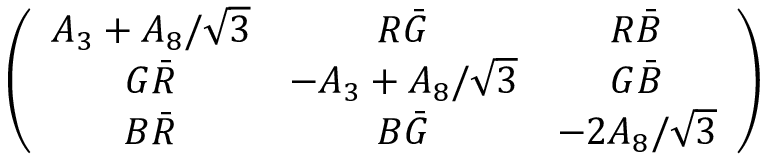Convert formula to latex. <formula><loc_0><loc_0><loc_500><loc_500>\left ( \begin{array} { c c c } { { A _ { 3 } + A _ { 8 } / \sqrt { 3 } } } & { { R \bar { G } } } & { { R \bar { B } } } \\ { { G \bar { R } } } & { { - A _ { 3 } + A _ { 8 } / \sqrt { 3 } } } & { { G \bar { B } } } \\ { { B \bar { R } } } & { { B \bar { G } } } & { { - 2 A _ { 8 } / \sqrt { 3 } } } \end{array} \right )</formula> 